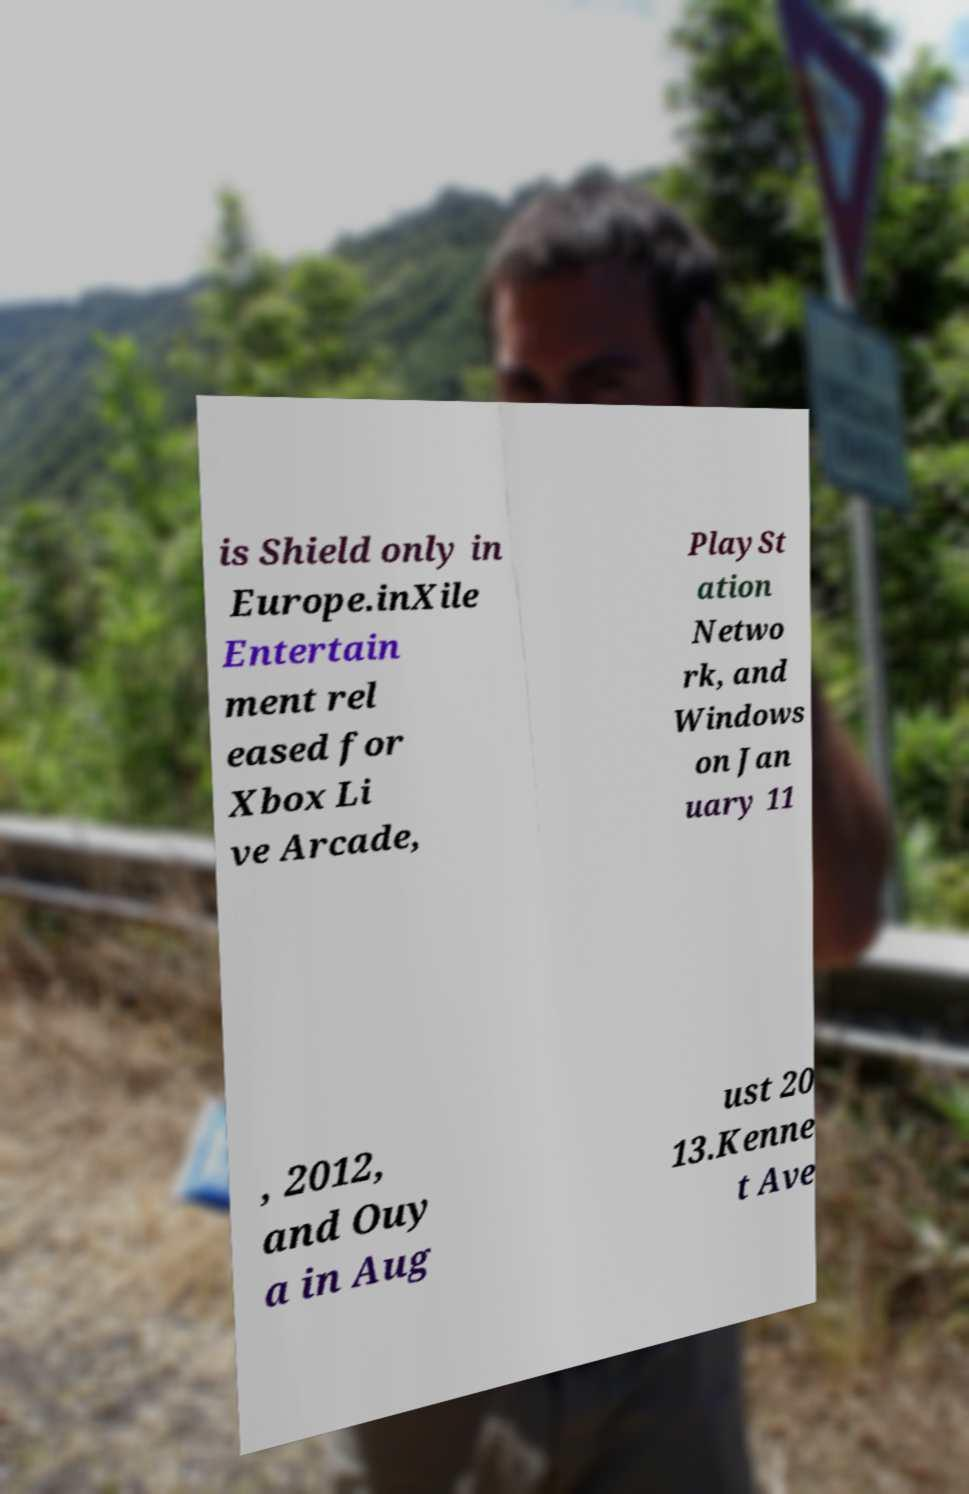Could you extract and type out the text from this image? is Shield only in Europe.inXile Entertain ment rel eased for Xbox Li ve Arcade, PlaySt ation Netwo rk, and Windows on Jan uary 11 , 2012, and Ouy a in Aug ust 20 13.Kenne t Ave 